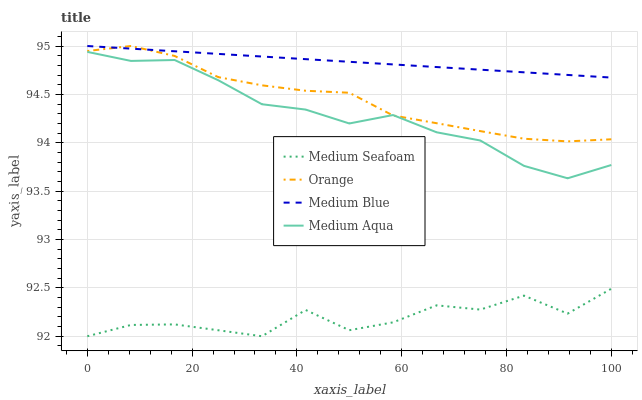Does Medium Seafoam have the minimum area under the curve?
Answer yes or no. Yes. Does Medium Blue have the maximum area under the curve?
Answer yes or no. Yes. Does Medium Aqua have the minimum area under the curve?
Answer yes or no. No. Does Medium Aqua have the maximum area under the curve?
Answer yes or no. No. Is Medium Blue the smoothest?
Answer yes or no. Yes. Is Medium Seafoam the roughest?
Answer yes or no. Yes. Is Medium Aqua the smoothest?
Answer yes or no. No. Is Medium Aqua the roughest?
Answer yes or no. No. Does Medium Seafoam have the lowest value?
Answer yes or no. Yes. Does Medium Aqua have the lowest value?
Answer yes or no. No. Does Medium Blue have the highest value?
Answer yes or no. Yes. Does Medium Aqua have the highest value?
Answer yes or no. No. Is Medium Seafoam less than Orange?
Answer yes or no. Yes. Is Medium Aqua greater than Medium Seafoam?
Answer yes or no. Yes. Does Orange intersect Medium Aqua?
Answer yes or no. Yes. Is Orange less than Medium Aqua?
Answer yes or no. No. Is Orange greater than Medium Aqua?
Answer yes or no. No. Does Medium Seafoam intersect Orange?
Answer yes or no. No. 